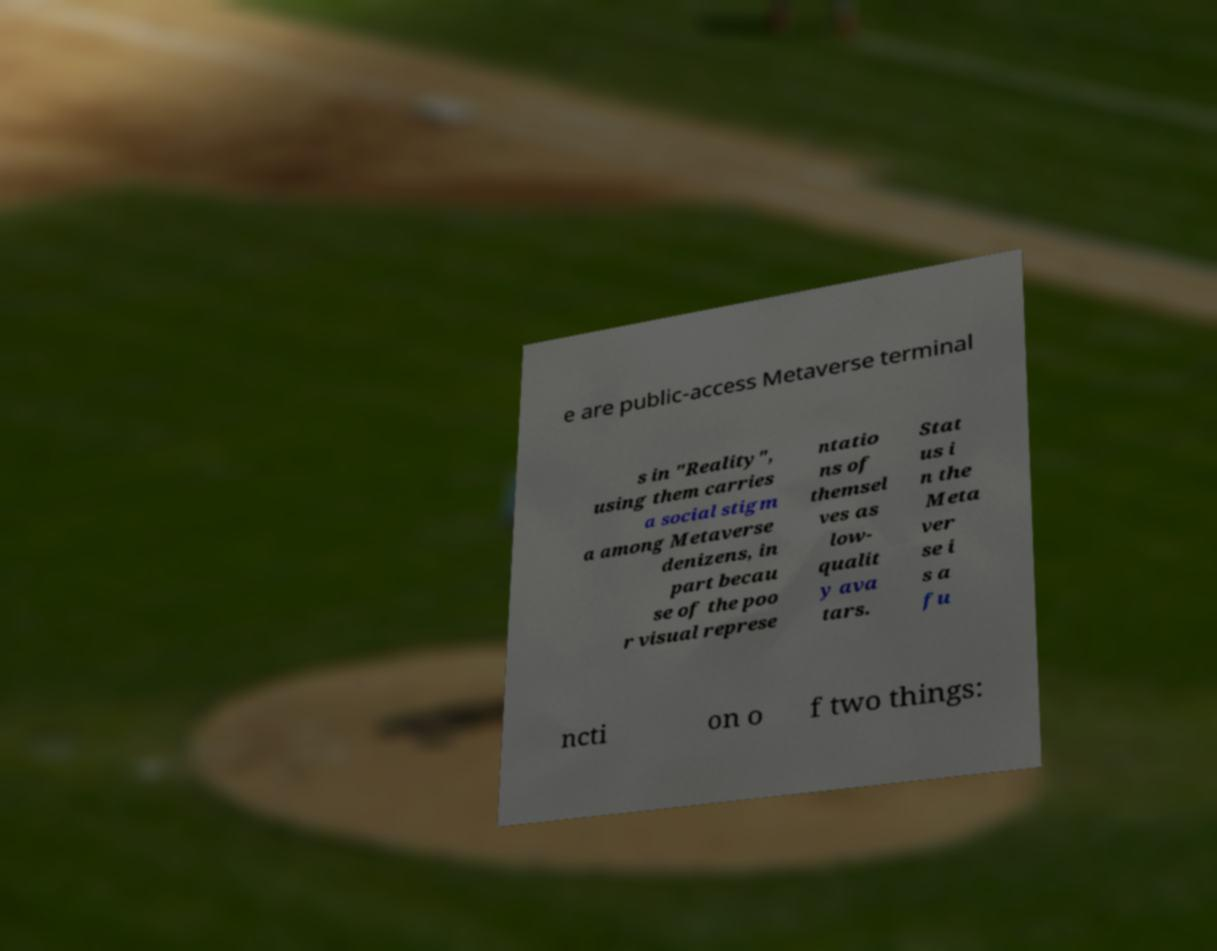Please read and relay the text visible in this image. What does it say? e are public-access Metaverse terminal s in "Reality", using them carries a social stigm a among Metaverse denizens, in part becau se of the poo r visual represe ntatio ns of themsel ves as low- qualit y ava tars. Stat us i n the Meta ver se i s a fu ncti on o f two things: 